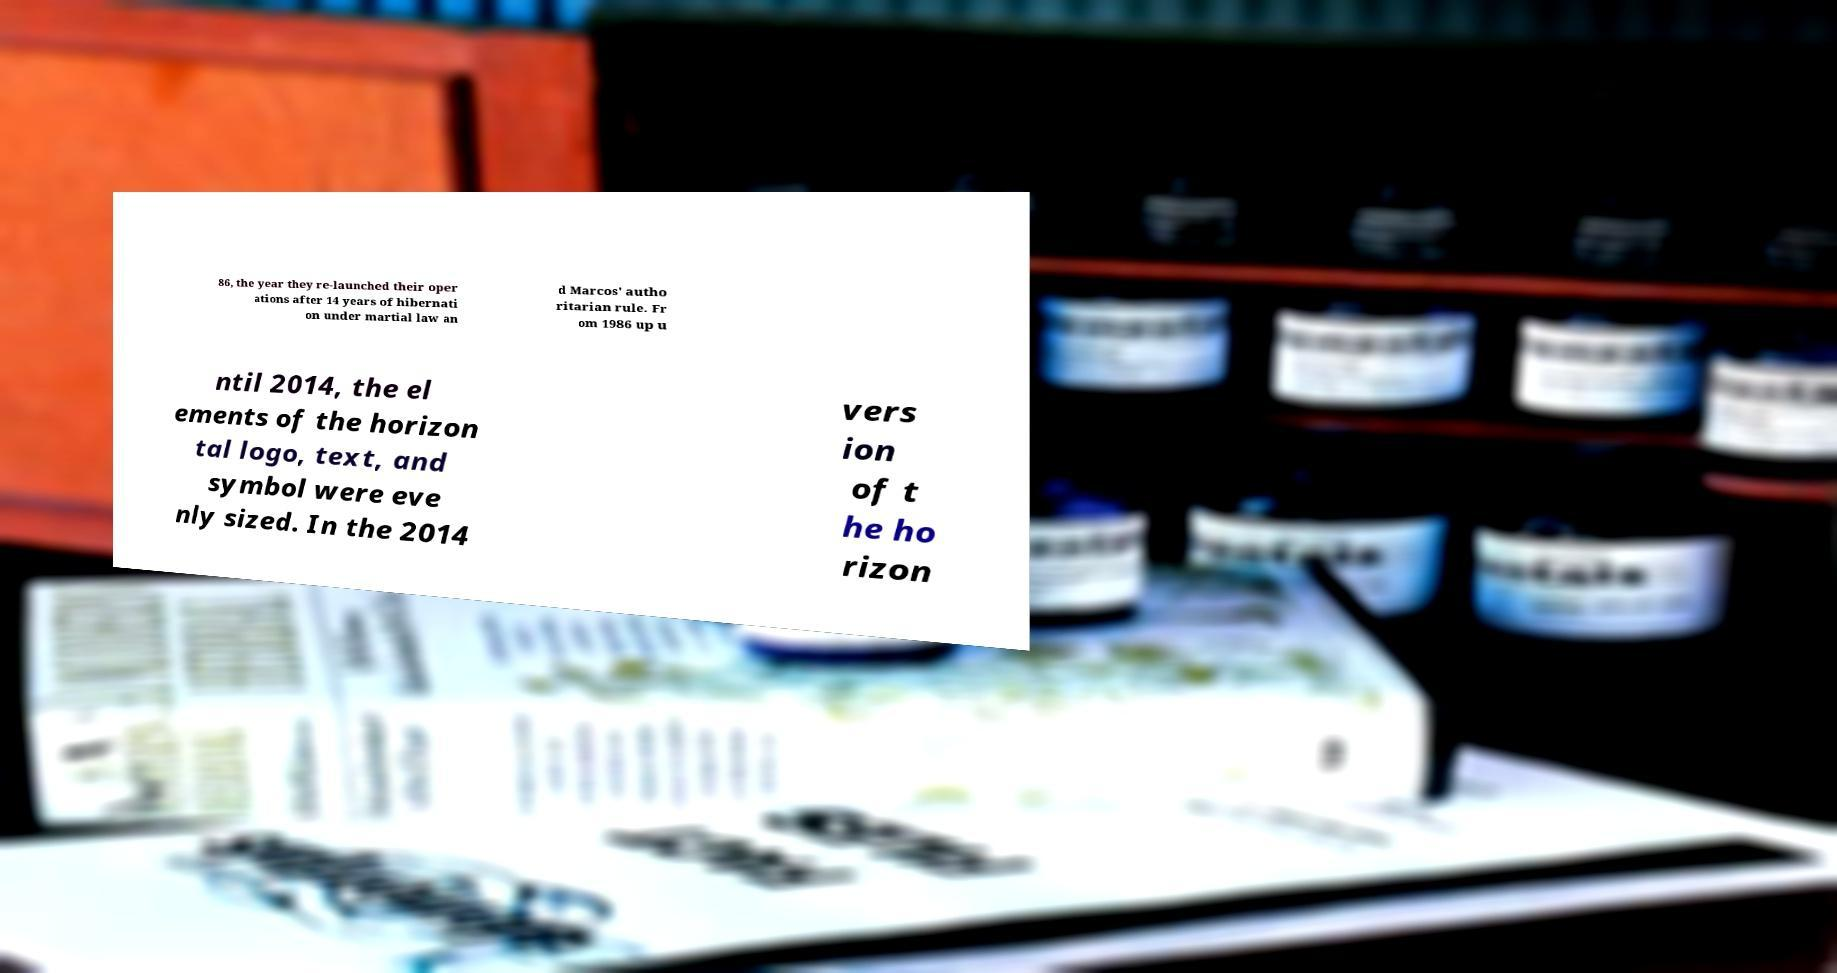Could you extract and type out the text from this image? 86, the year they re-launched their oper ations after 14 years of hibernati on under martial law an d Marcos' autho ritarian rule. Fr om 1986 up u ntil 2014, the el ements of the horizon tal logo, text, and symbol were eve nly sized. In the 2014 vers ion of t he ho rizon 